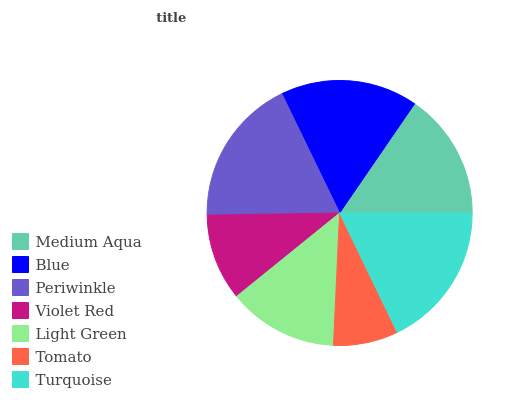Is Tomato the minimum?
Answer yes or no. Yes. Is Periwinkle the maximum?
Answer yes or no. Yes. Is Blue the minimum?
Answer yes or no. No. Is Blue the maximum?
Answer yes or no. No. Is Blue greater than Medium Aqua?
Answer yes or no. Yes. Is Medium Aqua less than Blue?
Answer yes or no. Yes. Is Medium Aqua greater than Blue?
Answer yes or no. No. Is Blue less than Medium Aqua?
Answer yes or no. No. Is Medium Aqua the high median?
Answer yes or no. Yes. Is Medium Aqua the low median?
Answer yes or no. Yes. Is Blue the high median?
Answer yes or no. No. Is Light Green the low median?
Answer yes or no. No. 